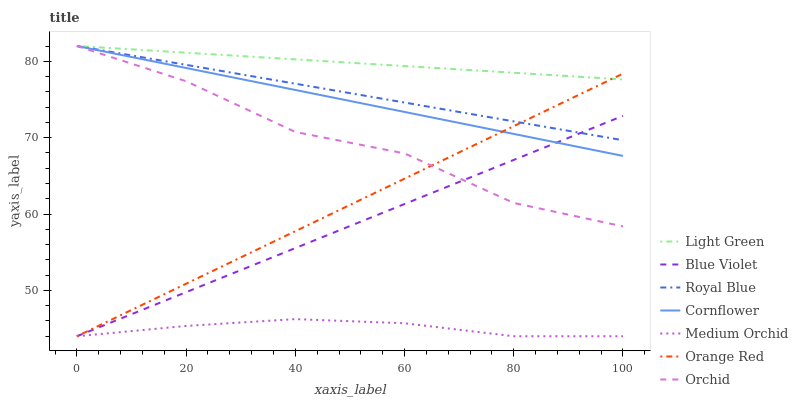Does Medium Orchid have the minimum area under the curve?
Answer yes or no. Yes. Does Light Green have the maximum area under the curve?
Answer yes or no. Yes. Does Royal Blue have the minimum area under the curve?
Answer yes or no. No. Does Royal Blue have the maximum area under the curve?
Answer yes or no. No. Is Blue Violet the smoothest?
Answer yes or no. Yes. Is Orchid the roughest?
Answer yes or no. Yes. Is Medium Orchid the smoothest?
Answer yes or no. No. Is Medium Orchid the roughest?
Answer yes or no. No. Does Medium Orchid have the lowest value?
Answer yes or no. Yes. Does Royal Blue have the lowest value?
Answer yes or no. No. Does Orchid have the highest value?
Answer yes or no. Yes. Does Medium Orchid have the highest value?
Answer yes or no. No. Is Blue Violet less than Light Green?
Answer yes or no. Yes. Is Royal Blue greater than Medium Orchid?
Answer yes or no. Yes. Does Cornflower intersect Light Green?
Answer yes or no. Yes. Is Cornflower less than Light Green?
Answer yes or no. No. Is Cornflower greater than Light Green?
Answer yes or no. No. Does Blue Violet intersect Light Green?
Answer yes or no. No. 